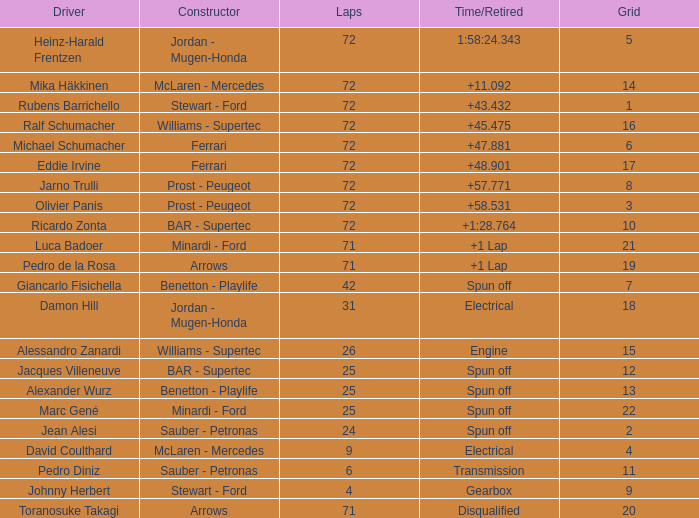In how many laps was ricardo zonta's grid position less than 14? 72.0. 